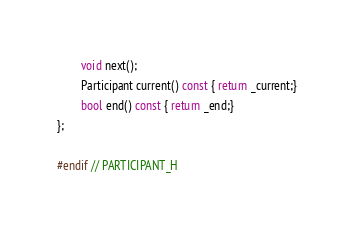<code> <loc_0><loc_0><loc_500><loc_500><_C_>        void next();
        Participant current() const { return _current;}
        bool end() const { return _end;}
};

#endif // PARTICIPANT_H
</code> 